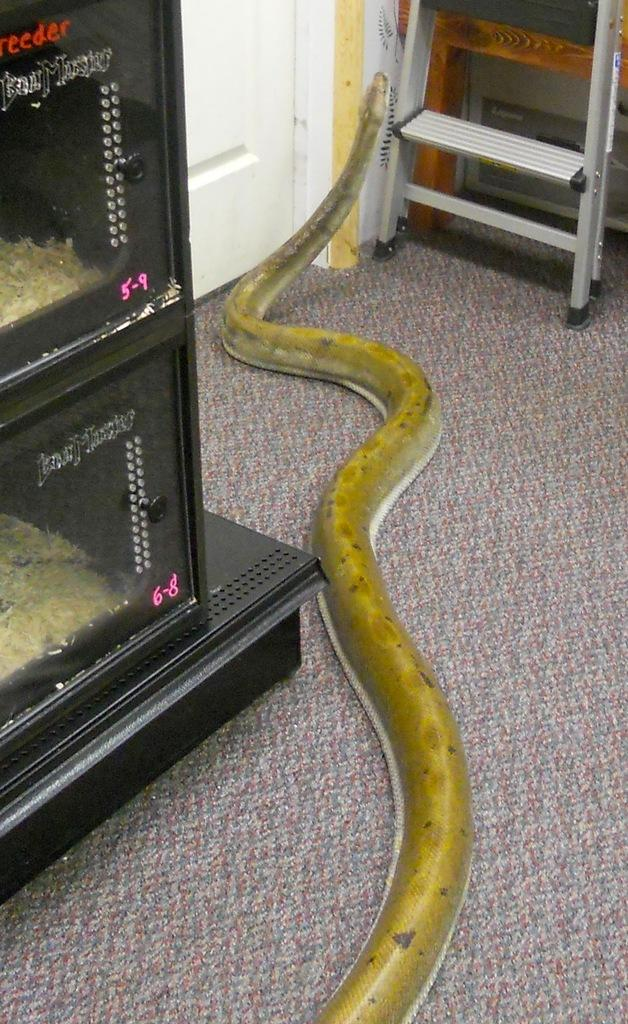What is the main subject in the center of the image? There is a snake in the center of the image. What architectural feature can be seen in the image? There is a door in the image. What is located at the top side of the image? There is a ladder at the top side of the image. What type of furniture is on the left side of the image? There are cupboards on the left side of the image. What nation is the writer from in the image? There is no writer or nation mentioned in the image; it features a snake, a door, a ladder, and cupboards. 